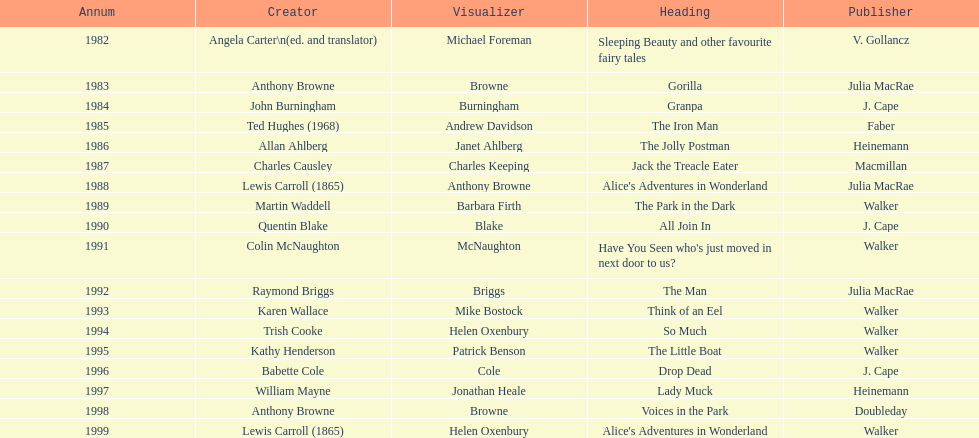What are the number of kurt maschler awards helen oxenbury has won? 2. Could you parse the entire table as a dict? {'header': ['Annum', 'Creator', 'Visualizer', 'Heading', 'Publisher'], 'rows': [['1982', 'Angela Carter\\n(ed. and translator)', 'Michael Foreman', 'Sleeping Beauty and other favourite fairy tales', 'V. Gollancz'], ['1983', 'Anthony Browne', 'Browne', 'Gorilla', 'Julia MacRae'], ['1984', 'John Burningham', 'Burningham', 'Granpa', 'J. Cape'], ['1985', 'Ted Hughes (1968)', 'Andrew Davidson', 'The Iron Man', 'Faber'], ['1986', 'Allan Ahlberg', 'Janet Ahlberg', 'The Jolly Postman', 'Heinemann'], ['1987', 'Charles Causley', 'Charles Keeping', 'Jack the Treacle Eater', 'Macmillan'], ['1988', 'Lewis Carroll (1865)', 'Anthony Browne', "Alice's Adventures in Wonderland", 'Julia MacRae'], ['1989', 'Martin Waddell', 'Barbara Firth', 'The Park in the Dark', 'Walker'], ['1990', 'Quentin Blake', 'Blake', 'All Join In', 'J. Cape'], ['1991', 'Colin McNaughton', 'McNaughton', "Have You Seen who's just moved in next door to us?", 'Walker'], ['1992', 'Raymond Briggs', 'Briggs', 'The Man', 'Julia MacRae'], ['1993', 'Karen Wallace', 'Mike Bostock', 'Think of an Eel', 'Walker'], ['1994', 'Trish Cooke', 'Helen Oxenbury', 'So Much', 'Walker'], ['1995', 'Kathy Henderson', 'Patrick Benson', 'The Little Boat', 'Walker'], ['1996', 'Babette Cole', 'Cole', 'Drop Dead', 'J. Cape'], ['1997', 'William Mayne', 'Jonathan Heale', 'Lady Muck', 'Heinemann'], ['1998', 'Anthony Browne', 'Browne', 'Voices in the Park', 'Doubleday'], ['1999', 'Lewis Carroll (1865)', 'Helen Oxenbury', "Alice's Adventures in Wonderland", 'Walker']]} 